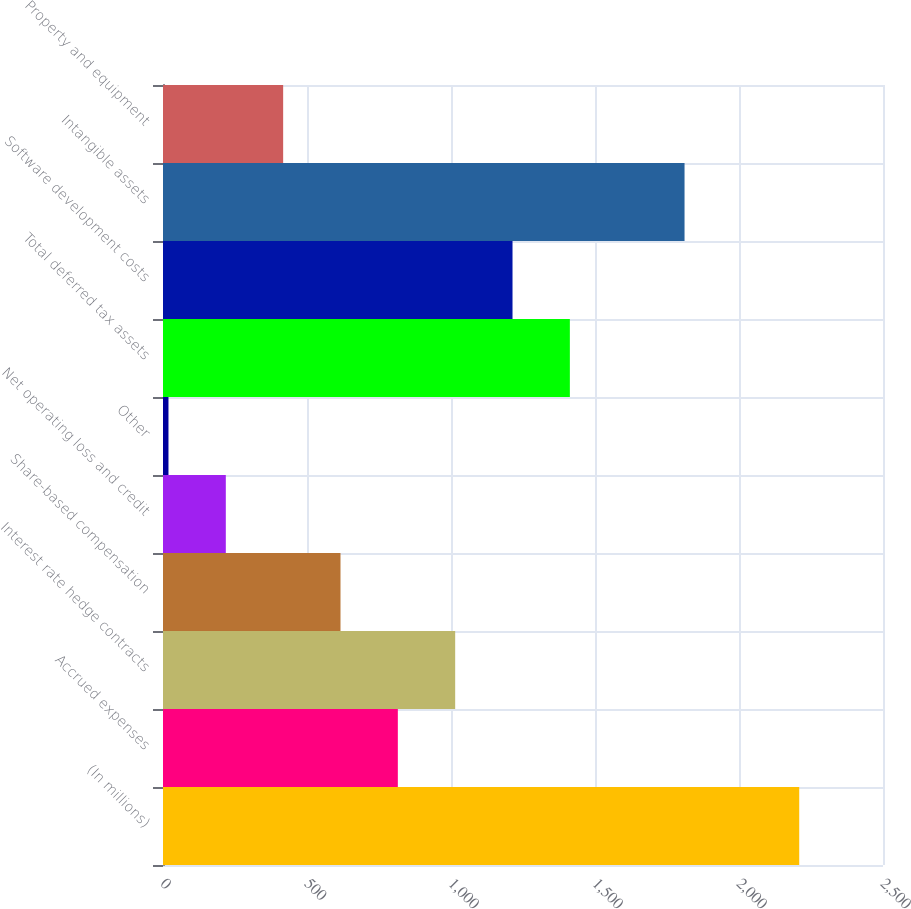Convert chart. <chart><loc_0><loc_0><loc_500><loc_500><bar_chart><fcel>(In millions)<fcel>Accrued expenses<fcel>Interest rate hedge contracts<fcel>Share-based compensation<fcel>Net operating loss and credit<fcel>Other<fcel>Total deferred tax assets<fcel>Software development costs<fcel>Intangible assets<fcel>Property and equipment<nl><fcel>2209.1<fcel>815.4<fcel>1014.5<fcel>616.3<fcel>218.1<fcel>19<fcel>1412.7<fcel>1213.6<fcel>1810.9<fcel>417.2<nl></chart> 